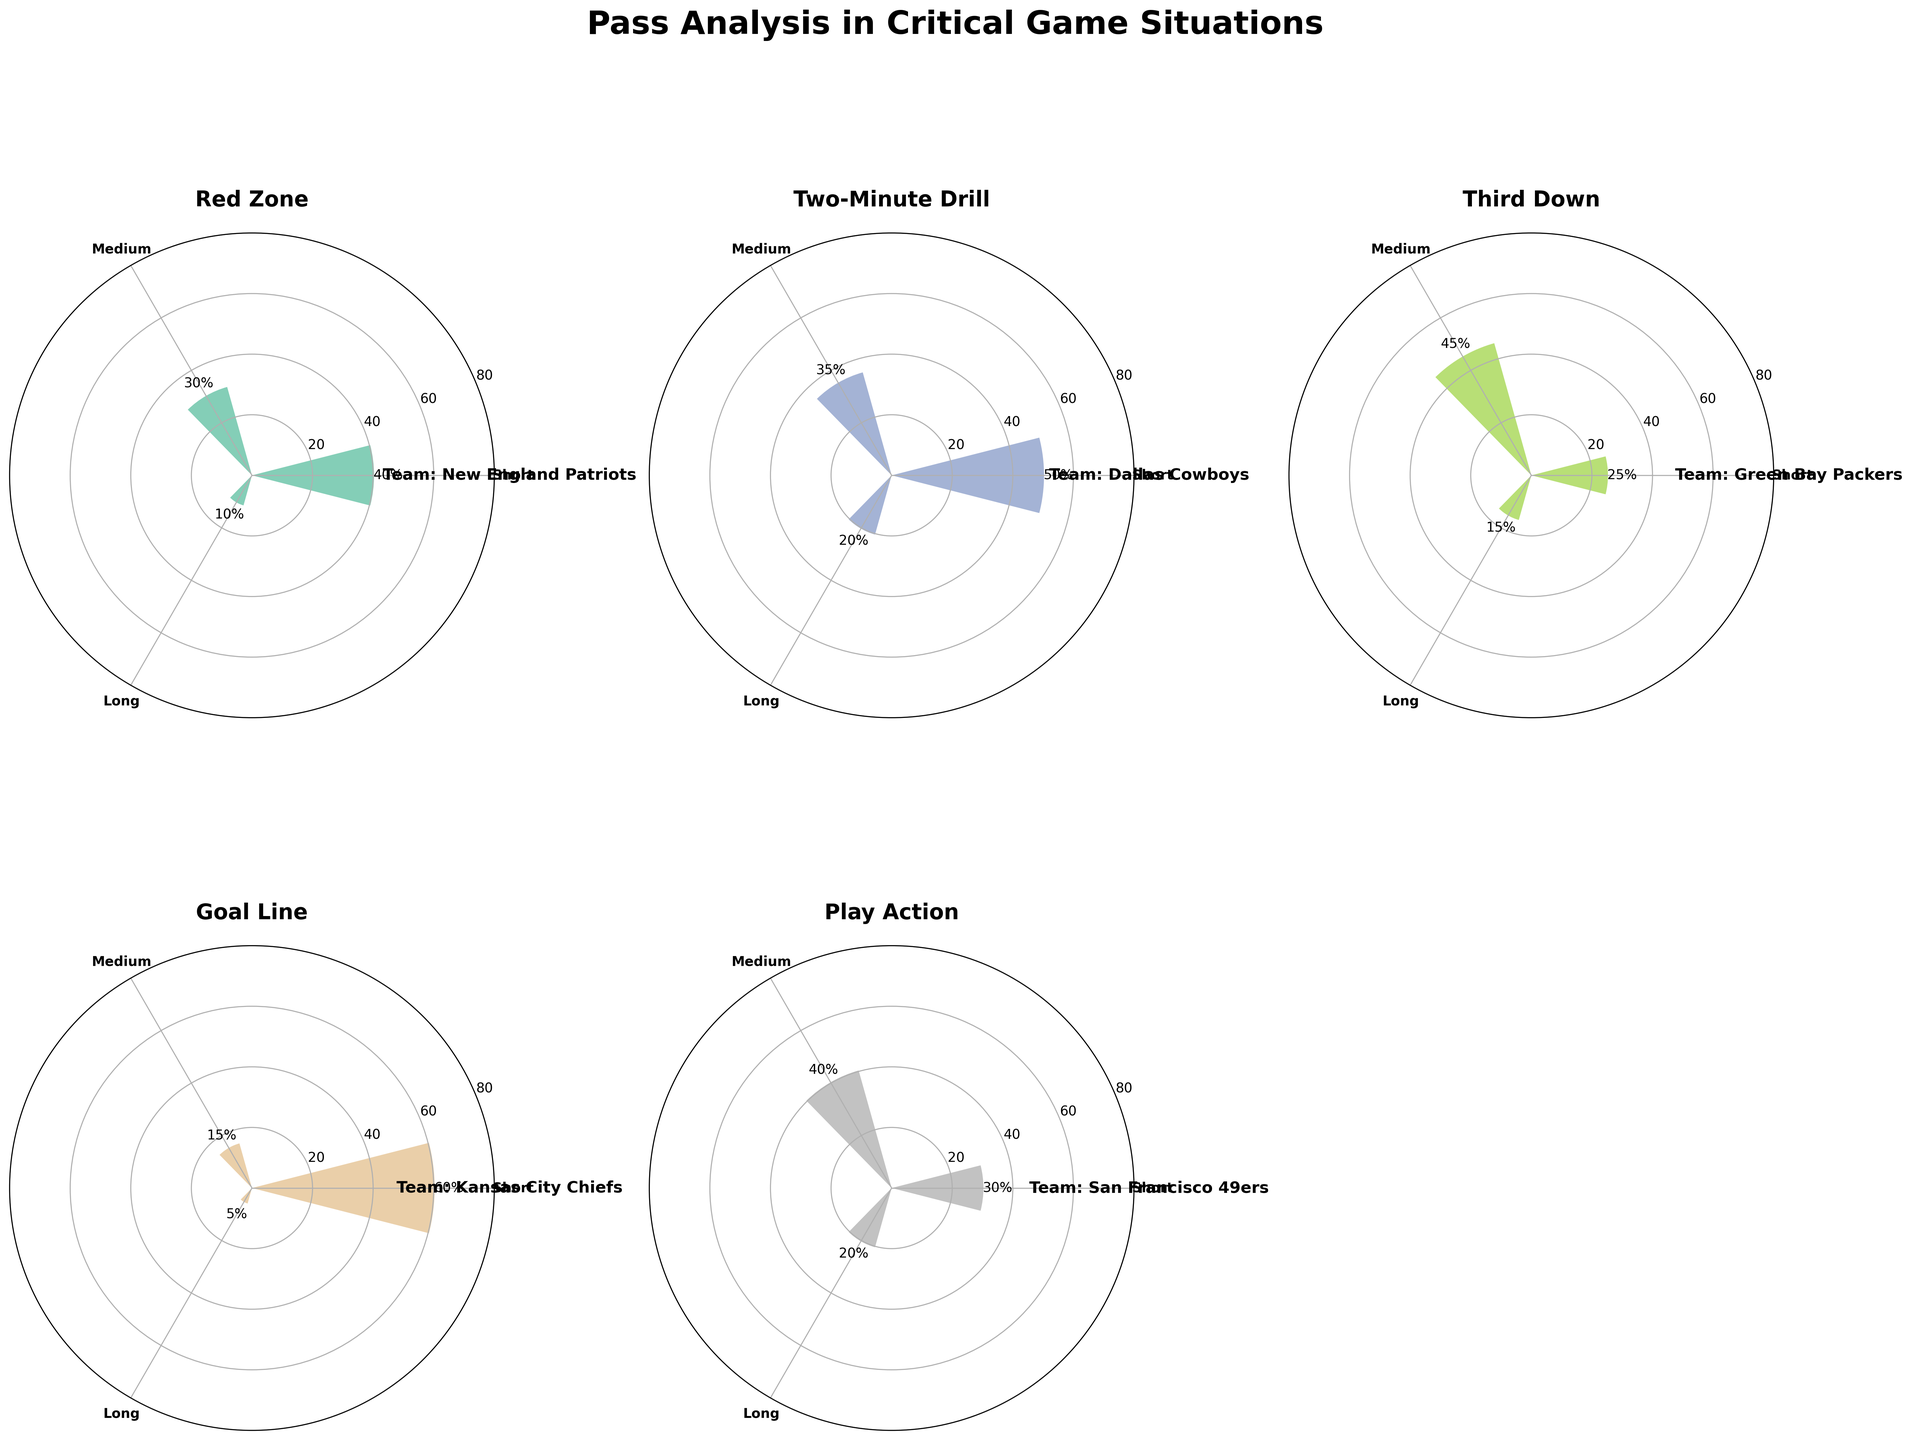what is the title of the figure? The title of the figure is typically found at the top center of the chart and provides a summary of what the chart is about. In this case, it should be centrally located above the plots.
Answer: Pass Analysis in Critical Game Situations which game situation has the highest frequency of short passes? To determine this, look at all the subplots and identify the highest bar representing short passes. In the 'Goal Line' subplot, the frequency of short passes reaches 60.
Answer: Goal Line how many game situations are covered in the figure? Each subplot represents a different game situation. Counting all the subplots gives the total number of game situations covered. There are five visible subplots.
Answer: 5 what's the frequency difference between medium passes and long passes for the Dallas Cowboys in the two-minute drill? Identify the frequencies for medium and long passes in the Two-Minute Drill subplot and subtract the smaller from the larger. Medium is 35, and long is 20, so the difference is 35 - 20 = 15.
Answer: 15 which team utilizes the highest frequency of short passes in the red zone? Look at the Red Zone subplot and identify the team with the highest bar for short passes. The New England Patriots have a frequency of 40 for short passes in the Red Zone.
Answer: New England Patriots which team has the highest total frequency of all types of passes combined in any single game situation? To find this out, you need the sum of frequencies of short, medium, and long passes for each team in each situation. Goal Line of Kansas City Chiefs: Short (60) + Medium (15) + Long (5) = 80. This is higher than other total frequencies.
Answer: Kansas City Chiefs which pass type has the lowest frequency in all game situations? Look at each subplot and identify the lowest frequency across all pass types. In the 'Goal Line' subplot, the frequency for long passes is 5, which is the lowest.
Answer: Long passes what is the average frequency of medium passes across all game situations? Sum the frequencies of medium passes from each subplot and divide by the number of game situations. (30 + 35 + 45 + 15 + 40) / 5 = 33.
Answer: 33 which game situation and team combination utilizes long passes the least? Identify the subplot with the smallest bar for long passes and note the game situation and team. In the 'Goal Line' subplot, Kansas City Chiefs use long passes the least with a frequency of 5.
Answer: Goal Line, Kansas City Chiefs 